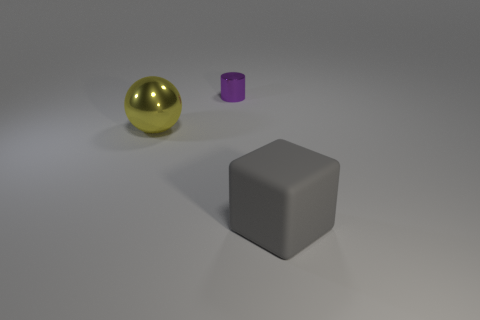Add 2 gray rubber objects. How many objects exist? 5 Subtract 1 balls. How many balls are left? 0 Subtract all tiny gray balls. Subtract all large rubber things. How many objects are left? 2 Add 1 cylinders. How many cylinders are left? 2 Add 2 yellow shiny things. How many yellow shiny things exist? 3 Subtract 0 yellow cylinders. How many objects are left? 3 Subtract all cylinders. How many objects are left? 2 Subtract all blue balls. Subtract all cyan cylinders. How many balls are left? 1 